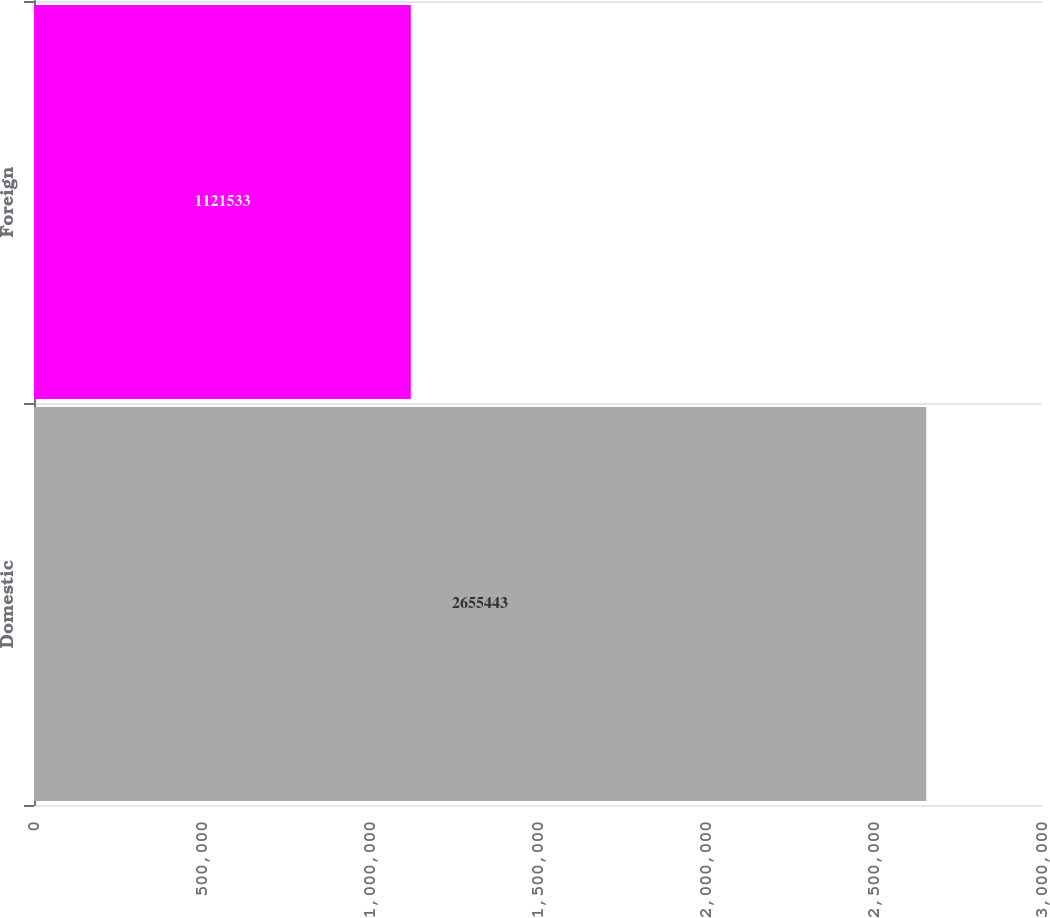Convert chart. <chart><loc_0><loc_0><loc_500><loc_500><bar_chart><fcel>Domestic<fcel>Foreign<nl><fcel>2.65544e+06<fcel>1.12153e+06<nl></chart> 